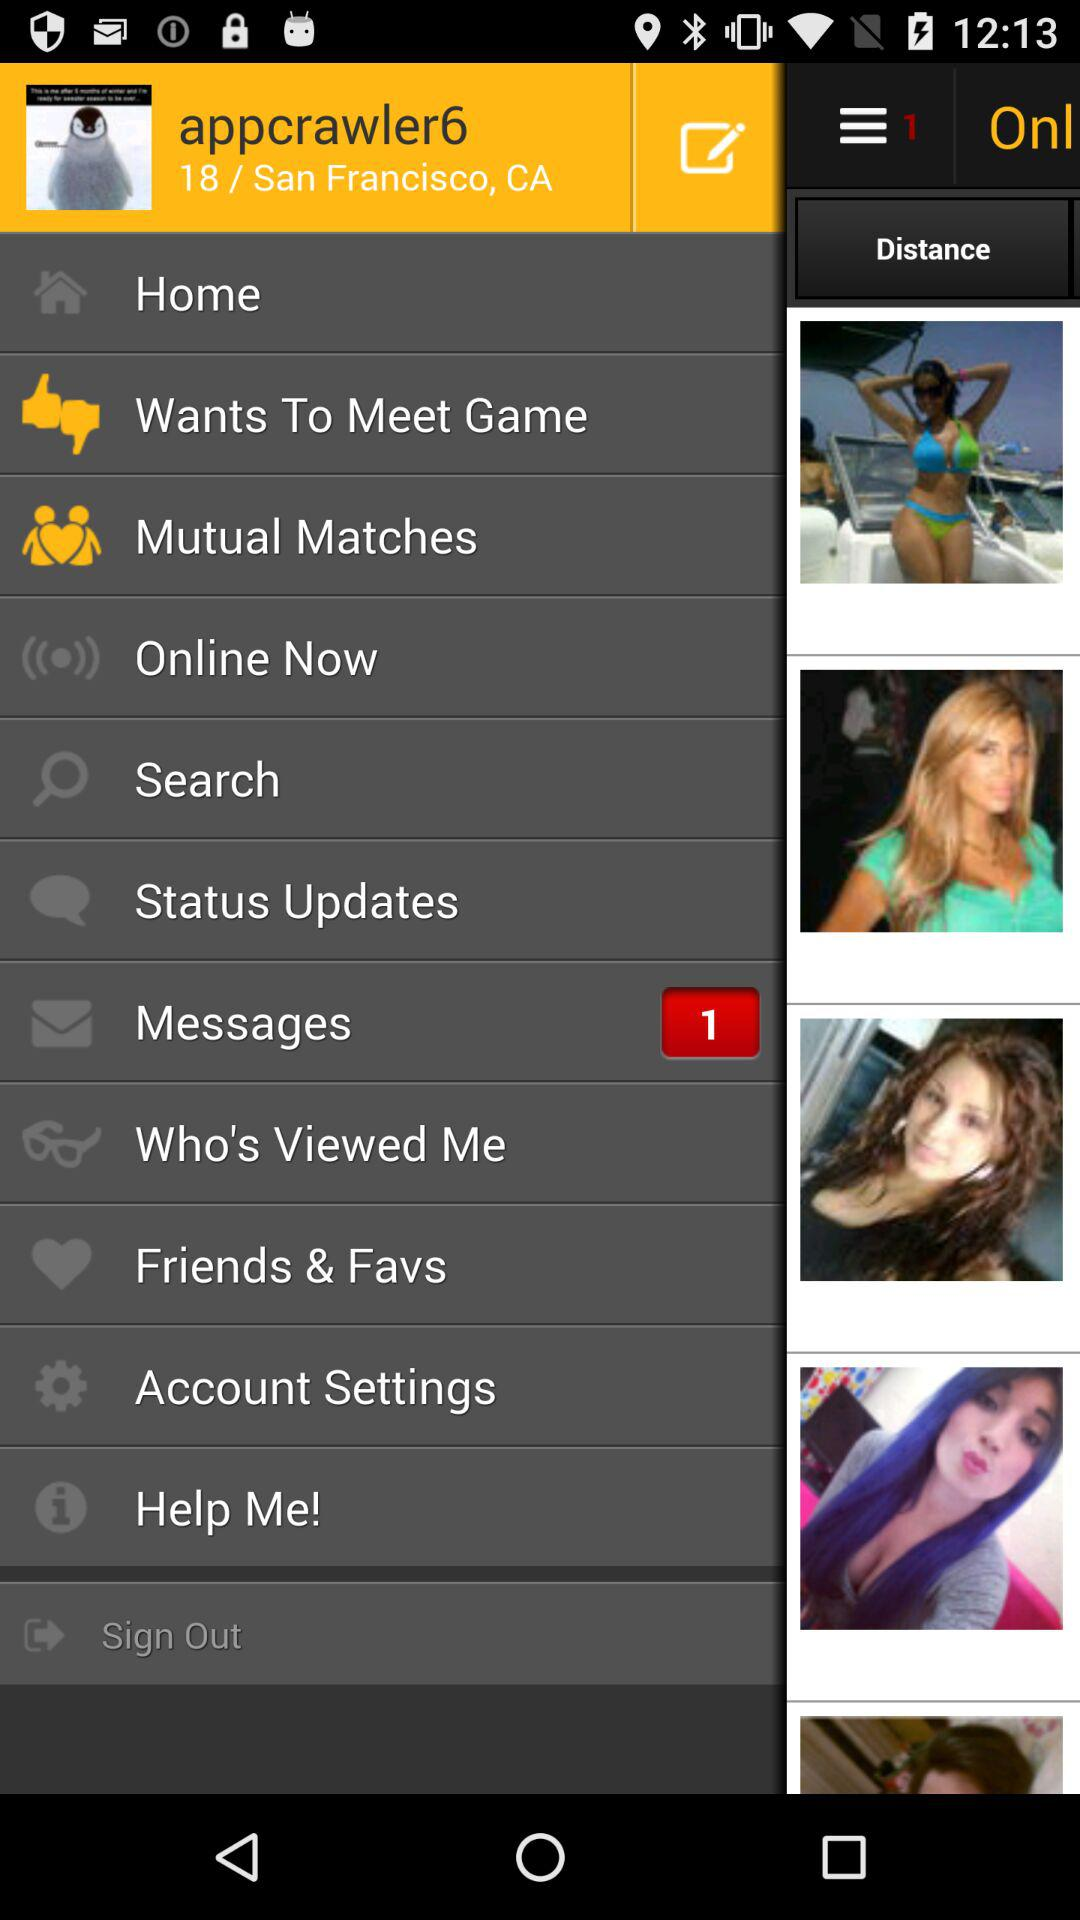What is the username? The username is "appcrawler6". 